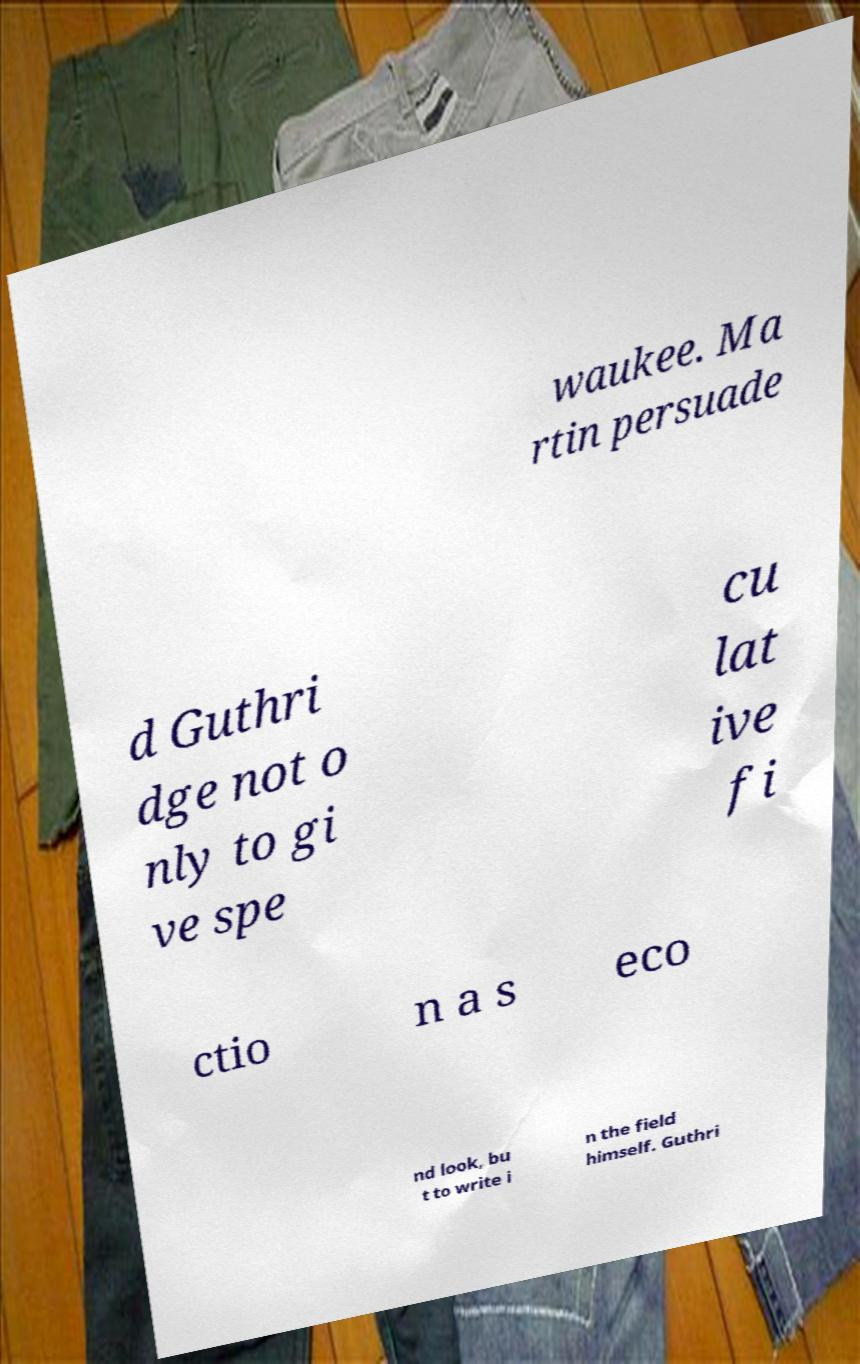For documentation purposes, I need the text within this image transcribed. Could you provide that? waukee. Ma rtin persuade d Guthri dge not o nly to gi ve spe cu lat ive fi ctio n a s eco nd look, bu t to write i n the field himself. Guthri 